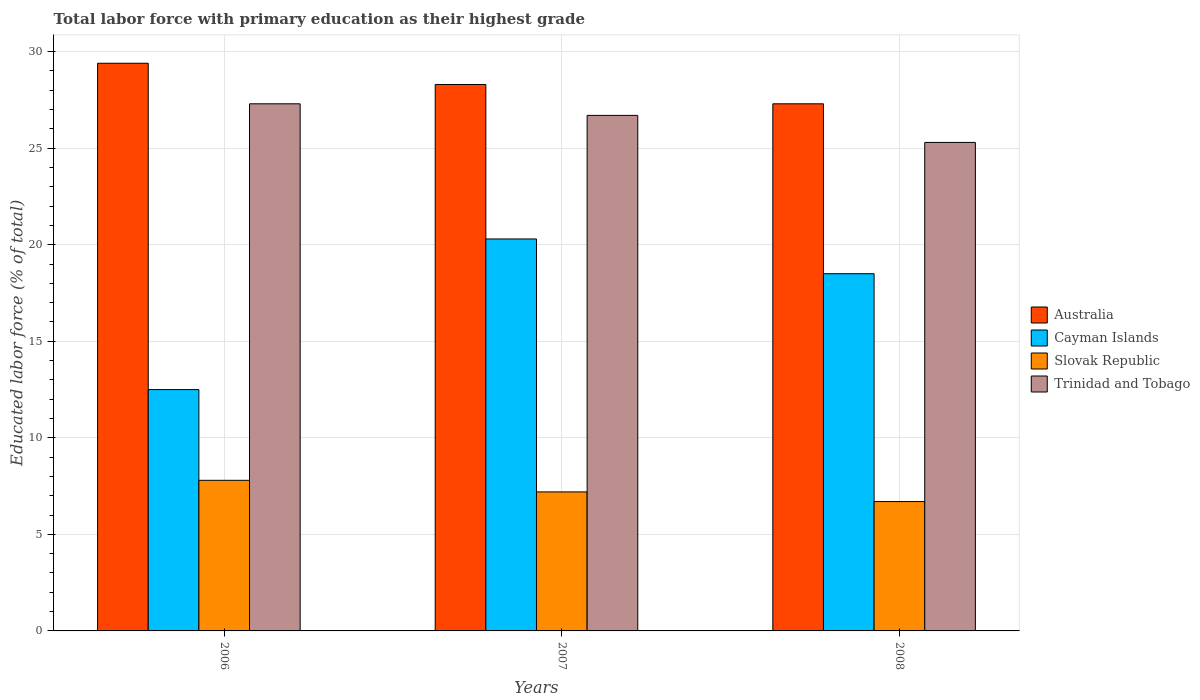How many groups of bars are there?
Make the answer very short. 3. How many bars are there on the 1st tick from the left?
Provide a short and direct response. 4. How many bars are there on the 3rd tick from the right?
Your response must be concise. 4. What is the percentage of total labor force with primary education in Trinidad and Tobago in 2008?
Ensure brevity in your answer.  25.3. Across all years, what is the maximum percentage of total labor force with primary education in Slovak Republic?
Your response must be concise. 7.8. Across all years, what is the minimum percentage of total labor force with primary education in Australia?
Ensure brevity in your answer.  27.3. In which year was the percentage of total labor force with primary education in Slovak Republic minimum?
Offer a very short reply. 2008. What is the total percentage of total labor force with primary education in Cayman Islands in the graph?
Your response must be concise. 51.3. What is the difference between the percentage of total labor force with primary education in Australia in 2007 and that in 2008?
Ensure brevity in your answer.  1. What is the difference between the percentage of total labor force with primary education in Trinidad and Tobago in 2007 and the percentage of total labor force with primary education in Cayman Islands in 2006?
Your answer should be very brief. 14.2. What is the average percentage of total labor force with primary education in Australia per year?
Make the answer very short. 28.33. In the year 2006, what is the difference between the percentage of total labor force with primary education in Australia and percentage of total labor force with primary education in Slovak Republic?
Ensure brevity in your answer.  21.6. In how many years, is the percentage of total labor force with primary education in Australia greater than 7 %?
Your response must be concise. 3. What is the ratio of the percentage of total labor force with primary education in Trinidad and Tobago in 2007 to that in 2008?
Your answer should be compact. 1.06. Is the percentage of total labor force with primary education in Trinidad and Tobago in 2007 less than that in 2008?
Your answer should be very brief. No. What is the difference between the highest and the second highest percentage of total labor force with primary education in Trinidad and Tobago?
Offer a terse response. 0.6. What is the difference between the highest and the lowest percentage of total labor force with primary education in Cayman Islands?
Offer a very short reply. 7.8. Is it the case that in every year, the sum of the percentage of total labor force with primary education in Cayman Islands and percentage of total labor force with primary education in Trinidad and Tobago is greater than the sum of percentage of total labor force with primary education in Australia and percentage of total labor force with primary education in Slovak Republic?
Your response must be concise. Yes. What does the 1st bar from the left in 2006 represents?
Provide a short and direct response. Australia. What does the 2nd bar from the right in 2006 represents?
Your response must be concise. Slovak Republic. How many bars are there?
Provide a short and direct response. 12. Are all the bars in the graph horizontal?
Your answer should be very brief. No. Does the graph contain grids?
Give a very brief answer. Yes. How many legend labels are there?
Offer a very short reply. 4. What is the title of the graph?
Offer a very short reply. Total labor force with primary education as their highest grade. What is the label or title of the Y-axis?
Keep it short and to the point. Educated labor force (% of total). What is the Educated labor force (% of total) of Australia in 2006?
Ensure brevity in your answer.  29.4. What is the Educated labor force (% of total) of Slovak Republic in 2006?
Offer a very short reply. 7.8. What is the Educated labor force (% of total) of Trinidad and Tobago in 2006?
Provide a short and direct response. 27.3. What is the Educated labor force (% of total) in Australia in 2007?
Your answer should be compact. 28.3. What is the Educated labor force (% of total) in Cayman Islands in 2007?
Your response must be concise. 20.3. What is the Educated labor force (% of total) in Slovak Republic in 2007?
Your answer should be very brief. 7.2. What is the Educated labor force (% of total) of Trinidad and Tobago in 2007?
Give a very brief answer. 26.7. What is the Educated labor force (% of total) in Australia in 2008?
Your answer should be compact. 27.3. What is the Educated labor force (% of total) of Slovak Republic in 2008?
Provide a succinct answer. 6.7. What is the Educated labor force (% of total) in Trinidad and Tobago in 2008?
Provide a succinct answer. 25.3. Across all years, what is the maximum Educated labor force (% of total) of Australia?
Keep it short and to the point. 29.4. Across all years, what is the maximum Educated labor force (% of total) in Cayman Islands?
Keep it short and to the point. 20.3. Across all years, what is the maximum Educated labor force (% of total) in Slovak Republic?
Make the answer very short. 7.8. Across all years, what is the maximum Educated labor force (% of total) of Trinidad and Tobago?
Your answer should be very brief. 27.3. Across all years, what is the minimum Educated labor force (% of total) of Australia?
Your answer should be compact. 27.3. Across all years, what is the minimum Educated labor force (% of total) in Cayman Islands?
Provide a succinct answer. 12.5. Across all years, what is the minimum Educated labor force (% of total) of Slovak Republic?
Provide a short and direct response. 6.7. Across all years, what is the minimum Educated labor force (% of total) in Trinidad and Tobago?
Make the answer very short. 25.3. What is the total Educated labor force (% of total) of Australia in the graph?
Ensure brevity in your answer.  85. What is the total Educated labor force (% of total) of Cayman Islands in the graph?
Offer a very short reply. 51.3. What is the total Educated labor force (% of total) of Slovak Republic in the graph?
Your answer should be compact. 21.7. What is the total Educated labor force (% of total) in Trinidad and Tobago in the graph?
Your answer should be compact. 79.3. What is the difference between the Educated labor force (% of total) in Australia in 2006 and that in 2008?
Make the answer very short. 2.1. What is the difference between the Educated labor force (% of total) in Cayman Islands in 2006 and that in 2008?
Provide a succinct answer. -6. What is the difference between the Educated labor force (% of total) of Slovak Republic in 2006 and that in 2008?
Ensure brevity in your answer.  1.1. What is the difference between the Educated labor force (% of total) in Australia in 2007 and that in 2008?
Make the answer very short. 1. What is the difference between the Educated labor force (% of total) in Australia in 2006 and the Educated labor force (% of total) in Cayman Islands in 2007?
Your response must be concise. 9.1. What is the difference between the Educated labor force (% of total) of Cayman Islands in 2006 and the Educated labor force (% of total) of Slovak Republic in 2007?
Make the answer very short. 5.3. What is the difference between the Educated labor force (% of total) in Slovak Republic in 2006 and the Educated labor force (% of total) in Trinidad and Tobago in 2007?
Your answer should be very brief. -18.9. What is the difference between the Educated labor force (% of total) of Australia in 2006 and the Educated labor force (% of total) of Slovak Republic in 2008?
Your answer should be compact. 22.7. What is the difference between the Educated labor force (% of total) of Cayman Islands in 2006 and the Educated labor force (% of total) of Trinidad and Tobago in 2008?
Ensure brevity in your answer.  -12.8. What is the difference between the Educated labor force (% of total) in Slovak Republic in 2006 and the Educated labor force (% of total) in Trinidad and Tobago in 2008?
Your response must be concise. -17.5. What is the difference between the Educated labor force (% of total) of Australia in 2007 and the Educated labor force (% of total) of Cayman Islands in 2008?
Your answer should be compact. 9.8. What is the difference between the Educated labor force (% of total) of Australia in 2007 and the Educated labor force (% of total) of Slovak Republic in 2008?
Your answer should be very brief. 21.6. What is the difference between the Educated labor force (% of total) of Cayman Islands in 2007 and the Educated labor force (% of total) of Trinidad and Tobago in 2008?
Your response must be concise. -5. What is the difference between the Educated labor force (% of total) in Slovak Republic in 2007 and the Educated labor force (% of total) in Trinidad and Tobago in 2008?
Your answer should be compact. -18.1. What is the average Educated labor force (% of total) in Australia per year?
Give a very brief answer. 28.33. What is the average Educated labor force (% of total) of Slovak Republic per year?
Offer a very short reply. 7.23. What is the average Educated labor force (% of total) in Trinidad and Tobago per year?
Provide a short and direct response. 26.43. In the year 2006, what is the difference between the Educated labor force (% of total) of Australia and Educated labor force (% of total) of Cayman Islands?
Your answer should be compact. 16.9. In the year 2006, what is the difference between the Educated labor force (% of total) in Australia and Educated labor force (% of total) in Slovak Republic?
Provide a succinct answer. 21.6. In the year 2006, what is the difference between the Educated labor force (% of total) in Australia and Educated labor force (% of total) in Trinidad and Tobago?
Offer a very short reply. 2.1. In the year 2006, what is the difference between the Educated labor force (% of total) of Cayman Islands and Educated labor force (% of total) of Trinidad and Tobago?
Your response must be concise. -14.8. In the year 2006, what is the difference between the Educated labor force (% of total) of Slovak Republic and Educated labor force (% of total) of Trinidad and Tobago?
Provide a short and direct response. -19.5. In the year 2007, what is the difference between the Educated labor force (% of total) in Australia and Educated labor force (% of total) in Cayman Islands?
Provide a succinct answer. 8. In the year 2007, what is the difference between the Educated labor force (% of total) of Australia and Educated labor force (% of total) of Slovak Republic?
Provide a short and direct response. 21.1. In the year 2007, what is the difference between the Educated labor force (% of total) in Cayman Islands and Educated labor force (% of total) in Slovak Republic?
Ensure brevity in your answer.  13.1. In the year 2007, what is the difference between the Educated labor force (% of total) of Slovak Republic and Educated labor force (% of total) of Trinidad and Tobago?
Offer a terse response. -19.5. In the year 2008, what is the difference between the Educated labor force (% of total) in Australia and Educated labor force (% of total) in Slovak Republic?
Give a very brief answer. 20.6. In the year 2008, what is the difference between the Educated labor force (% of total) of Australia and Educated labor force (% of total) of Trinidad and Tobago?
Your answer should be very brief. 2. In the year 2008, what is the difference between the Educated labor force (% of total) in Cayman Islands and Educated labor force (% of total) in Trinidad and Tobago?
Offer a terse response. -6.8. In the year 2008, what is the difference between the Educated labor force (% of total) in Slovak Republic and Educated labor force (% of total) in Trinidad and Tobago?
Give a very brief answer. -18.6. What is the ratio of the Educated labor force (% of total) of Australia in 2006 to that in 2007?
Your answer should be compact. 1.04. What is the ratio of the Educated labor force (% of total) of Cayman Islands in 2006 to that in 2007?
Offer a terse response. 0.62. What is the ratio of the Educated labor force (% of total) in Slovak Republic in 2006 to that in 2007?
Your response must be concise. 1.08. What is the ratio of the Educated labor force (% of total) of Trinidad and Tobago in 2006 to that in 2007?
Provide a succinct answer. 1.02. What is the ratio of the Educated labor force (% of total) of Australia in 2006 to that in 2008?
Provide a short and direct response. 1.08. What is the ratio of the Educated labor force (% of total) in Cayman Islands in 2006 to that in 2008?
Offer a terse response. 0.68. What is the ratio of the Educated labor force (% of total) of Slovak Republic in 2006 to that in 2008?
Provide a short and direct response. 1.16. What is the ratio of the Educated labor force (% of total) in Trinidad and Tobago in 2006 to that in 2008?
Provide a succinct answer. 1.08. What is the ratio of the Educated labor force (% of total) of Australia in 2007 to that in 2008?
Give a very brief answer. 1.04. What is the ratio of the Educated labor force (% of total) of Cayman Islands in 2007 to that in 2008?
Give a very brief answer. 1.1. What is the ratio of the Educated labor force (% of total) of Slovak Republic in 2007 to that in 2008?
Offer a terse response. 1.07. What is the ratio of the Educated labor force (% of total) in Trinidad and Tobago in 2007 to that in 2008?
Provide a succinct answer. 1.06. What is the difference between the highest and the second highest Educated labor force (% of total) of Australia?
Offer a very short reply. 1.1. What is the difference between the highest and the second highest Educated labor force (% of total) in Cayman Islands?
Offer a very short reply. 1.8. What is the difference between the highest and the second highest Educated labor force (% of total) of Slovak Republic?
Make the answer very short. 0.6. What is the difference between the highest and the second highest Educated labor force (% of total) in Trinidad and Tobago?
Your answer should be compact. 0.6. 